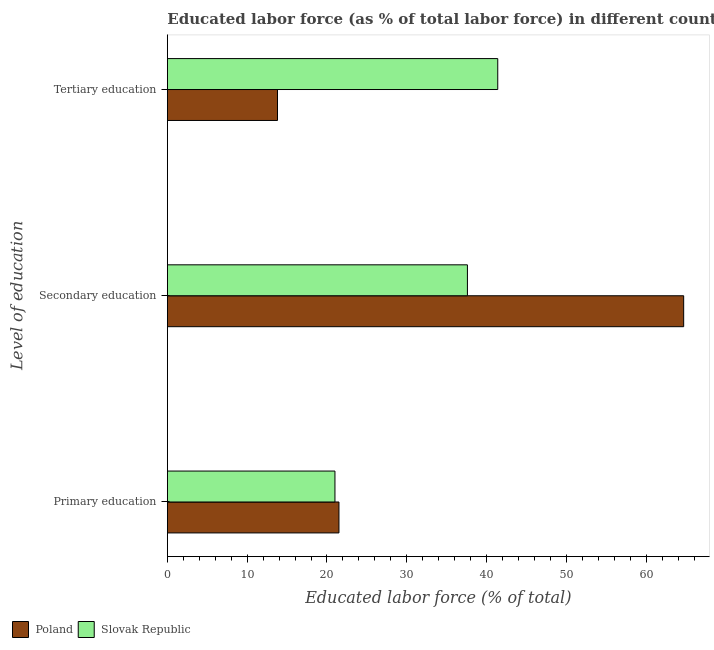Are the number of bars per tick equal to the number of legend labels?
Ensure brevity in your answer.  Yes. How many bars are there on the 3rd tick from the top?
Your response must be concise. 2. How many bars are there on the 2nd tick from the bottom?
Make the answer very short. 2. What is the label of the 1st group of bars from the top?
Give a very brief answer. Tertiary education. What is the percentage of labor force who received tertiary education in Poland?
Ensure brevity in your answer.  13.8. Across all countries, what is the maximum percentage of labor force who received secondary education?
Provide a succinct answer. 64.7. Across all countries, what is the minimum percentage of labor force who received tertiary education?
Keep it short and to the point. 13.8. In which country was the percentage of labor force who received primary education maximum?
Your answer should be compact. Poland. In which country was the percentage of labor force who received primary education minimum?
Your answer should be very brief. Slovak Republic. What is the total percentage of labor force who received secondary education in the graph?
Give a very brief answer. 102.3. What is the difference between the percentage of labor force who received tertiary education in Poland and that in Slovak Republic?
Make the answer very short. -27.6. What is the difference between the percentage of labor force who received primary education in Poland and the percentage of labor force who received tertiary education in Slovak Republic?
Offer a terse response. -19.9. What is the average percentage of labor force who received secondary education per country?
Your response must be concise. 51.15. What is the difference between the percentage of labor force who received primary education and percentage of labor force who received secondary education in Poland?
Ensure brevity in your answer.  -43.2. In how many countries, is the percentage of labor force who received primary education greater than 40 %?
Your answer should be very brief. 0. What is the ratio of the percentage of labor force who received secondary education in Slovak Republic to that in Poland?
Provide a succinct answer. 0.58. Is the difference between the percentage of labor force who received tertiary education in Poland and Slovak Republic greater than the difference between the percentage of labor force who received primary education in Poland and Slovak Republic?
Provide a short and direct response. No. What is the difference between the highest and the second highest percentage of labor force who received secondary education?
Ensure brevity in your answer.  27.1. Is the sum of the percentage of labor force who received primary education in Slovak Republic and Poland greater than the maximum percentage of labor force who received tertiary education across all countries?
Keep it short and to the point. Yes. What does the 2nd bar from the top in Secondary education represents?
Offer a very short reply. Poland. What does the 2nd bar from the bottom in Primary education represents?
Ensure brevity in your answer.  Slovak Republic. Is it the case that in every country, the sum of the percentage of labor force who received primary education and percentage of labor force who received secondary education is greater than the percentage of labor force who received tertiary education?
Your answer should be compact. Yes. How many bars are there?
Make the answer very short. 6. Are all the bars in the graph horizontal?
Provide a succinct answer. Yes. How many countries are there in the graph?
Offer a very short reply. 2. What is the difference between two consecutive major ticks on the X-axis?
Make the answer very short. 10. Are the values on the major ticks of X-axis written in scientific E-notation?
Offer a very short reply. No. Does the graph contain any zero values?
Offer a very short reply. No. Does the graph contain grids?
Provide a succinct answer. No. Where does the legend appear in the graph?
Ensure brevity in your answer.  Bottom left. How are the legend labels stacked?
Your answer should be very brief. Horizontal. What is the title of the graph?
Your response must be concise. Educated labor force (as % of total labor force) in different countries in 1995. What is the label or title of the X-axis?
Give a very brief answer. Educated labor force (% of total). What is the label or title of the Y-axis?
Provide a short and direct response. Level of education. What is the Educated labor force (% of total) of Poland in Primary education?
Your answer should be very brief. 21.5. What is the Educated labor force (% of total) in Slovak Republic in Primary education?
Provide a short and direct response. 21. What is the Educated labor force (% of total) in Poland in Secondary education?
Provide a succinct answer. 64.7. What is the Educated labor force (% of total) of Slovak Republic in Secondary education?
Your response must be concise. 37.6. What is the Educated labor force (% of total) of Poland in Tertiary education?
Keep it short and to the point. 13.8. What is the Educated labor force (% of total) of Slovak Republic in Tertiary education?
Offer a very short reply. 41.4. Across all Level of education, what is the maximum Educated labor force (% of total) of Poland?
Offer a very short reply. 64.7. Across all Level of education, what is the maximum Educated labor force (% of total) in Slovak Republic?
Offer a terse response. 41.4. Across all Level of education, what is the minimum Educated labor force (% of total) in Poland?
Ensure brevity in your answer.  13.8. What is the total Educated labor force (% of total) of Slovak Republic in the graph?
Offer a terse response. 100. What is the difference between the Educated labor force (% of total) in Poland in Primary education and that in Secondary education?
Provide a short and direct response. -43.2. What is the difference between the Educated labor force (% of total) in Slovak Republic in Primary education and that in Secondary education?
Offer a very short reply. -16.6. What is the difference between the Educated labor force (% of total) in Poland in Primary education and that in Tertiary education?
Provide a short and direct response. 7.7. What is the difference between the Educated labor force (% of total) of Slovak Republic in Primary education and that in Tertiary education?
Provide a short and direct response. -20.4. What is the difference between the Educated labor force (% of total) in Poland in Secondary education and that in Tertiary education?
Your answer should be very brief. 50.9. What is the difference between the Educated labor force (% of total) in Poland in Primary education and the Educated labor force (% of total) in Slovak Republic in Secondary education?
Make the answer very short. -16.1. What is the difference between the Educated labor force (% of total) in Poland in Primary education and the Educated labor force (% of total) in Slovak Republic in Tertiary education?
Keep it short and to the point. -19.9. What is the difference between the Educated labor force (% of total) of Poland in Secondary education and the Educated labor force (% of total) of Slovak Republic in Tertiary education?
Offer a very short reply. 23.3. What is the average Educated labor force (% of total) in Poland per Level of education?
Provide a succinct answer. 33.33. What is the average Educated labor force (% of total) of Slovak Republic per Level of education?
Provide a short and direct response. 33.33. What is the difference between the Educated labor force (% of total) of Poland and Educated labor force (% of total) of Slovak Republic in Primary education?
Offer a terse response. 0.5. What is the difference between the Educated labor force (% of total) of Poland and Educated labor force (% of total) of Slovak Republic in Secondary education?
Offer a very short reply. 27.1. What is the difference between the Educated labor force (% of total) of Poland and Educated labor force (% of total) of Slovak Republic in Tertiary education?
Offer a very short reply. -27.6. What is the ratio of the Educated labor force (% of total) of Poland in Primary education to that in Secondary education?
Ensure brevity in your answer.  0.33. What is the ratio of the Educated labor force (% of total) of Slovak Republic in Primary education to that in Secondary education?
Offer a terse response. 0.56. What is the ratio of the Educated labor force (% of total) of Poland in Primary education to that in Tertiary education?
Keep it short and to the point. 1.56. What is the ratio of the Educated labor force (% of total) of Slovak Republic in Primary education to that in Tertiary education?
Make the answer very short. 0.51. What is the ratio of the Educated labor force (% of total) in Poland in Secondary education to that in Tertiary education?
Give a very brief answer. 4.69. What is the ratio of the Educated labor force (% of total) of Slovak Republic in Secondary education to that in Tertiary education?
Provide a succinct answer. 0.91. What is the difference between the highest and the second highest Educated labor force (% of total) in Poland?
Ensure brevity in your answer.  43.2. What is the difference between the highest and the second highest Educated labor force (% of total) of Slovak Republic?
Offer a very short reply. 3.8. What is the difference between the highest and the lowest Educated labor force (% of total) of Poland?
Ensure brevity in your answer.  50.9. What is the difference between the highest and the lowest Educated labor force (% of total) in Slovak Republic?
Provide a short and direct response. 20.4. 